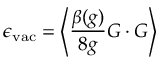<formula> <loc_0><loc_0><loc_500><loc_500>\epsilon _ { v a c } = \left < \frac { \beta ( g ) } { 8 g } G \cdot G \right ></formula> 